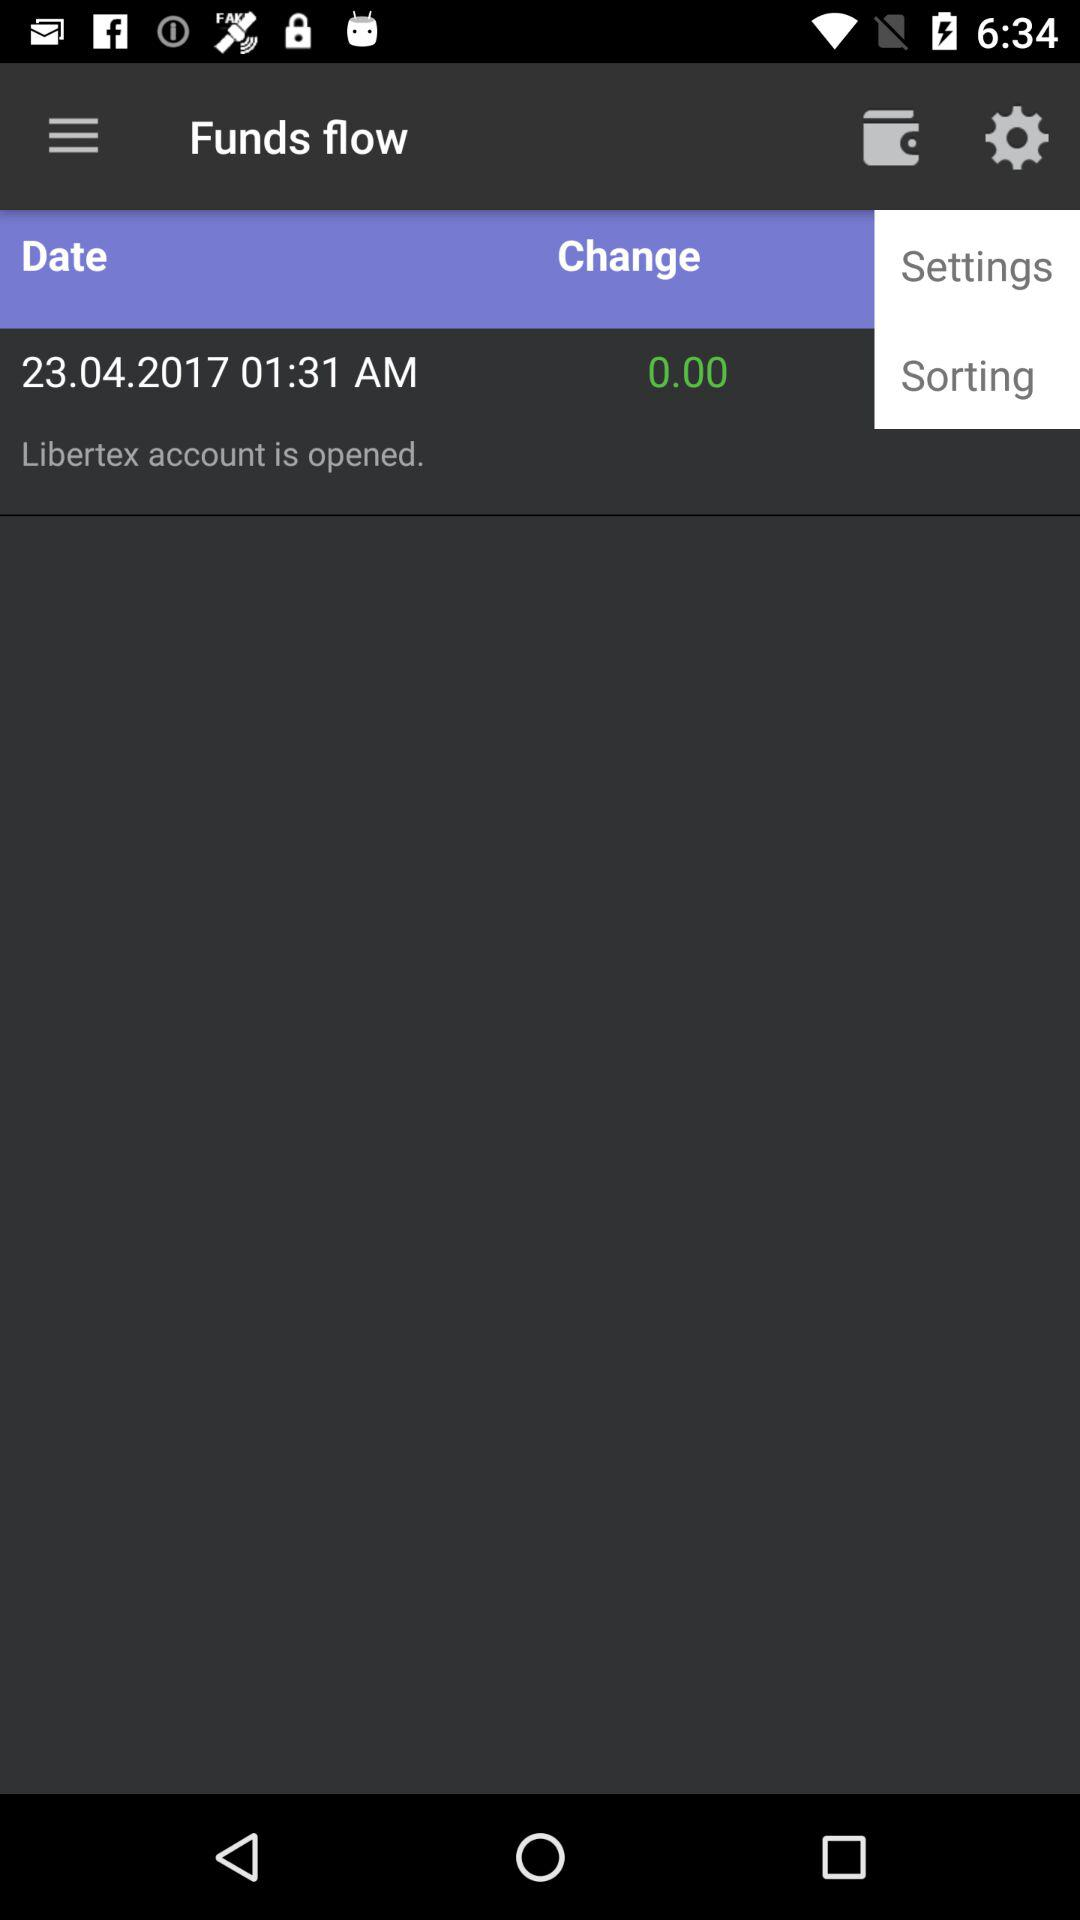What time was the account opened? The account was opened at 1:31 AM. 